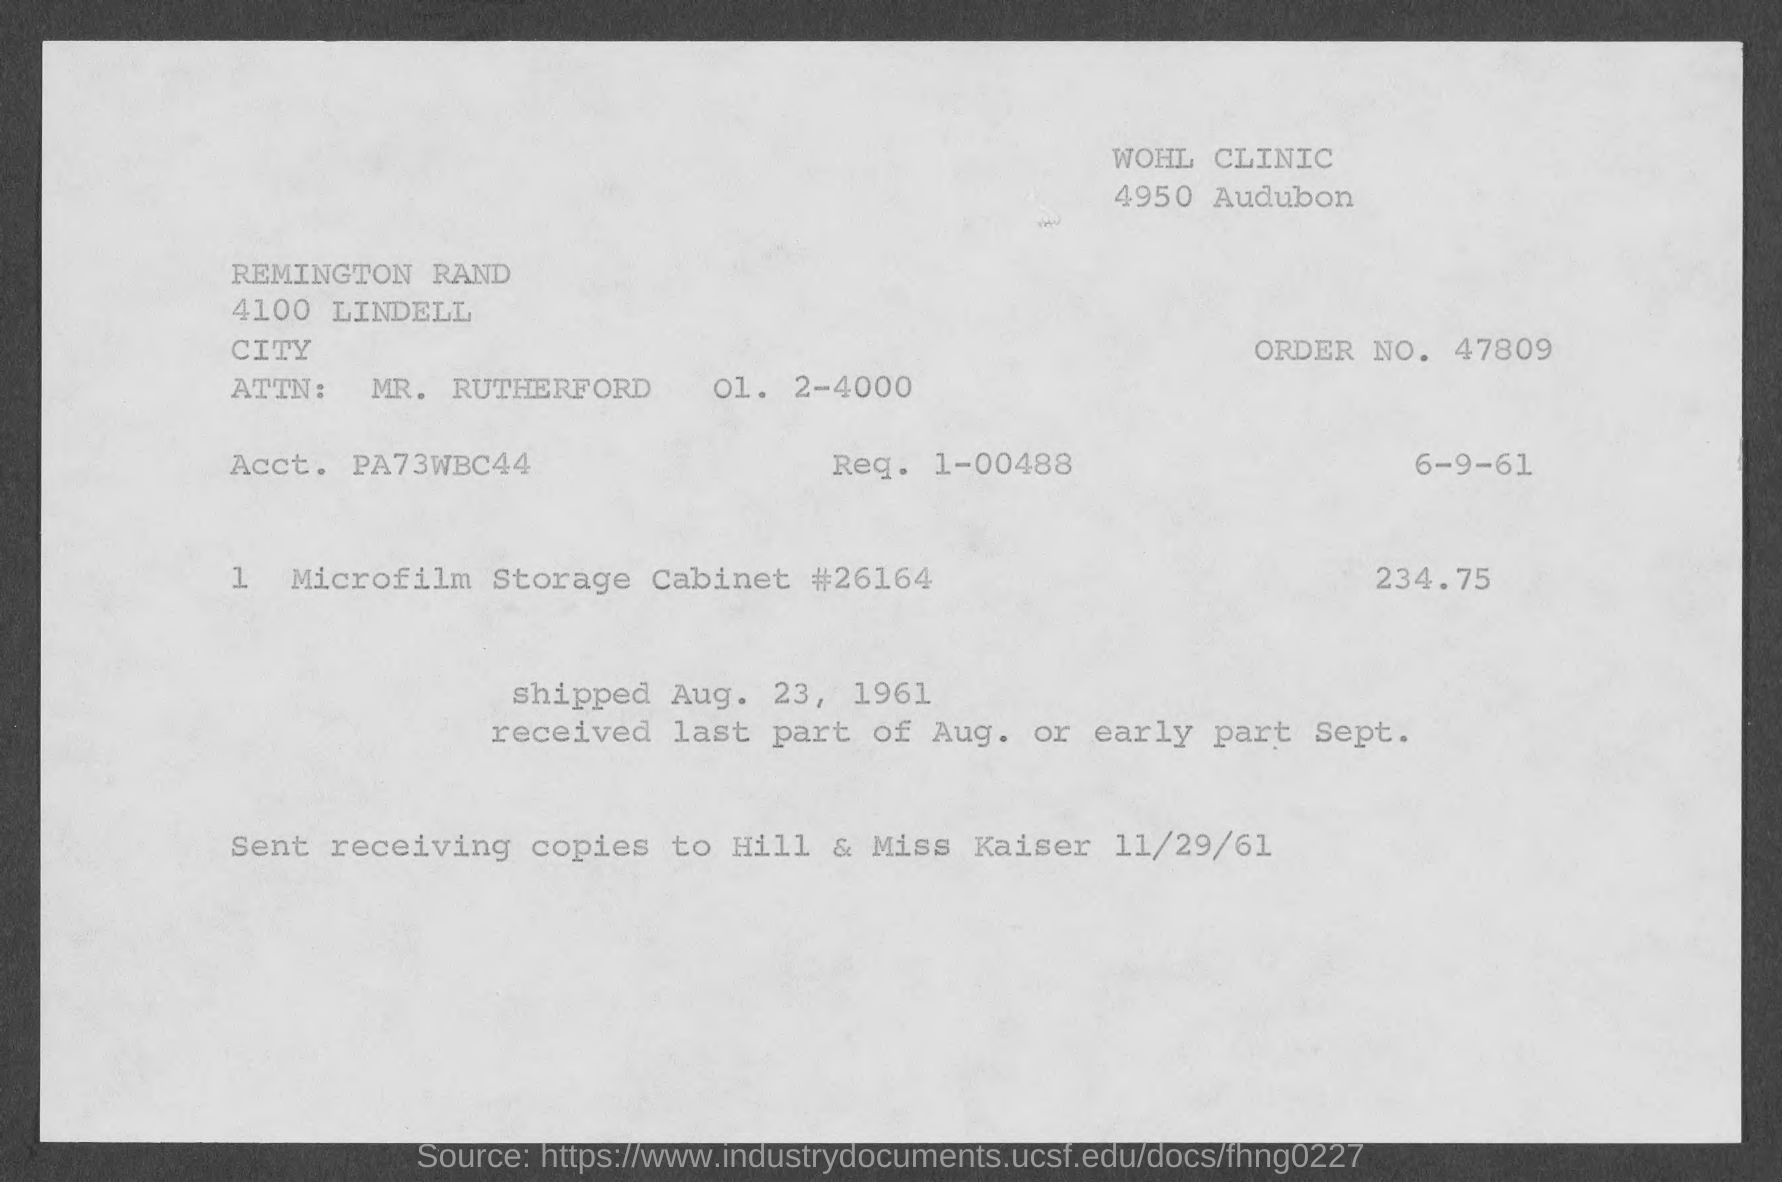What is the order no. mentioned in the given page ?
Provide a succinct answer. 47809. What is the attn: mentioned in the given form ?
Your answer should be compact. MR. Rutherford. What is the shipped date mentioned in the given page ?
Offer a very short reply. Aug. 23, 1961. What is the amount mentioned in the given form ?
Give a very brief answer. 234.75. 